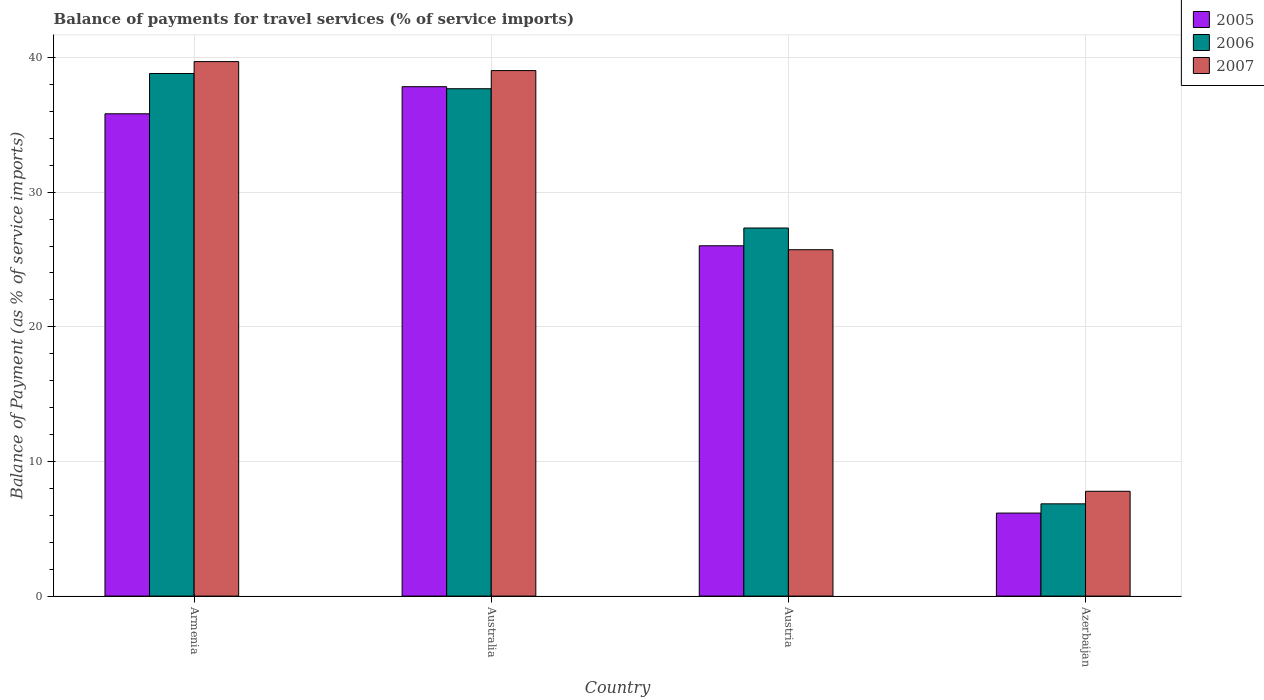How many different coloured bars are there?
Your answer should be compact. 3. Are the number of bars per tick equal to the number of legend labels?
Offer a terse response. Yes. How many bars are there on the 3rd tick from the right?
Keep it short and to the point. 3. What is the label of the 1st group of bars from the left?
Keep it short and to the point. Armenia. What is the balance of payments for travel services in 2005 in Armenia?
Your answer should be very brief. 35.82. Across all countries, what is the maximum balance of payments for travel services in 2006?
Provide a succinct answer. 38.81. Across all countries, what is the minimum balance of payments for travel services in 2006?
Make the answer very short. 6.85. In which country was the balance of payments for travel services in 2007 maximum?
Your response must be concise. Armenia. In which country was the balance of payments for travel services in 2006 minimum?
Give a very brief answer. Azerbaijan. What is the total balance of payments for travel services in 2005 in the graph?
Provide a short and direct response. 105.84. What is the difference between the balance of payments for travel services in 2006 in Armenia and that in Australia?
Your answer should be compact. 1.13. What is the difference between the balance of payments for travel services in 2006 in Armenia and the balance of payments for travel services in 2007 in Azerbaijan?
Offer a very short reply. 31.03. What is the average balance of payments for travel services in 2006 per country?
Provide a succinct answer. 27.67. What is the difference between the balance of payments for travel services of/in 2007 and balance of payments for travel services of/in 2006 in Austria?
Provide a succinct answer. -1.61. In how many countries, is the balance of payments for travel services in 2007 greater than 30 %?
Make the answer very short. 2. What is the ratio of the balance of payments for travel services in 2006 in Armenia to that in Australia?
Give a very brief answer. 1.03. Is the difference between the balance of payments for travel services in 2007 in Australia and Austria greater than the difference between the balance of payments for travel services in 2006 in Australia and Austria?
Offer a terse response. Yes. What is the difference between the highest and the second highest balance of payments for travel services in 2007?
Keep it short and to the point. -13.31. What is the difference between the highest and the lowest balance of payments for travel services in 2007?
Offer a very short reply. 31.91. In how many countries, is the balance of payments for travel services in 2005 greater than the average balance of payments for travel services in 2005 taken over all countries?
Offer a very short reply. 2. Is the sum of the balance of payments for travel services in 2006 in Armenia and Australia greater than the maximum balance of payments for travel services in 2007 across all countries?
Your answer should be very brief. Yes. What does the 2nd bar from the left in Azerbaijan represents?
Provide a short and direct response. 2006. How many bars are there?
Your response must be concise. 12. How many countries are there in the graph?
Offer a very short reply. 4. How many legend labels are there?
Your answer should be compact. 3. How are the legend labels stacked?
Make the answer very short. Vertical. What is the title of the graph?
Your answer should be compact. Balance of payments for travel services (% of service imports). Does "2015" appear as one of the legend labels in the graph?
Make the answer very short. No. What is the label or title of the X-axis?
Offer a very short reply. Country. What is the label or title of the Y-axis?
Provide a short and direct response. Balance of Payment (as % of service imports). What is the Balance of Payment (as % of service imports) in 2005 in Armenia?
Your response must be concise. 35.82. What is the Balance of Payment (as % of service imports) of 2006 in Armenia?
Offer a very short reply. 38.81. What is the Balance of Payment (as % of service imports) of 2007 in Armenia?
Your answer should be very brief. 39.7. What is the Balance of Payment (as % of service imports) of 2005 in Australia?
Offer a terse response. 37.83. What is the Balance of Payment (as % of service imports) of 2006 in Australia?
Give a very brief answer. 37.68. What is the Balance of Payment (as % of service imports) of 2007 in Australia?
Ensure brevity in your answer.  39.03. What is the Balance of Payment (as % of service imports) in 2005 in Austria?
Ensure brevity in your answer.  26.02. What is the Balance of Payment (as % of service imports) in 2006 in Austria?
Provide a short and direct response. 27.34. What is the Balance of Payment (as % of service imports) of 2007 in Austria?
Offer a terse response. 25.73. What is the Balance of Payment (as % of service imports) of 2005 in Azerbaijan?
Your response must be concise. 6.17. What is the Balance of Payment (as % of service imports) of 2006 in Azerbaijan?
Your response must be concise. 6.85. What is the Balance of Payment (as % of service imports) in 2007 in Azerbaijan?
Your response must be concise. 7.79. Across all countries, what is the maximum Balance of Payment (as % of service imports) of 2005?
Provide a succinct answer. 37.83. Across all countries, what is the maximum Balance of Payment (as % of service imports) in 2006?
Make the answer very short. 38.81. Across all countries, what is the maximum Balance of Payment (as % of service imports) in 2007?
Make the answer very short. 39.7. Across all countries, what is the minimum Balance of Payment (as % of service imports) in 2005?
Ensure brevity in your answer.  6.17. Across all countries, what is the minimum Balance of Payment (as % of service imports) of 2006?
Offer a very short reply. 6.85. Across all countries, what is the minimum Balance of Payment (as % of service imports) in 2007?
Keep it short and to the point. 7.79. What is the total Balance of Payment (as % of service imports) of 2005 in the graph?
Your answer should be very brief. 105.84. What is the total Balance of Payment (as % of service imports) of 2006 in the graph?
Your answer should be very brief. 110.69. What is the total Balance of Payment (as % of service imports) of 2007 in the graph?
Your answer should be very brief. 112.24. What is the difference between the Balance of Payment (as % of service imports) in 2005 in Armenia and that in Australia?
Provide a short and direct response. -2.01. What is the difference between the Balance of Payment (as % of service imports) in 2006 in Armenia and that in Australia?
Make the answer very short. 1.13. What is the difference between the Balance of Payment (as % of service imports) in 2007 in Armenia and that in Australia?
Your answer should be very brief. 0.67. What is the difference between the Balance of Payment (as % of service imports) of 2005 in Armenia and that in Austria?
Provide a succinct answer. 9.8. What is the difference between the Balance of Payment (as % of service imports) in 2006 in Armenia and that in Austria?
Provide a short and direct response. 11.47. What is the difference between the Balance of Payment (as % of service imports) of 2007 in Armenia and that in Austria?
Offer a terse response. 13.97. What is the difference between the Balance of Payment (as % of service imports) of 2005 in Armenia and that in Azerbaijan?
Give a very brief answer. 29.66. What is the difference between the Balance of Payment (as % of service imports) in 2006 in Armenia and that in Azerbaijan?
Make the answer very short. 31.96. What is the difference between the Balance of Payment (as % of service imports) in 2007 in Armenia and that in Azerbaijan?
Provide a succinct answer. 31.91. What is the difference between the Balance of Payment (as % of service imports) of 2005 in Australia and that in Austria?
Make the answer very short. 11.82. What is the difference between the Balance of Payment (as % of service imports) in 2006 in Australia and that in Austria?
Your response must be concise. 10.34. What is the difference between the Balance of Payment (as % of service imports) in 2007 in Australia and that in Austria?
Keep it short and to the point. 13.31. What is the difference between the Balance of Payment (as % of service imports) of 2005 in Australia and that in Azerbaijan?
Keep it short and to the point. 31.67. What is the difference between the Balance of Payment (as % of service imports) of 2006 in Australia and that in Azerbaijan?
Your response must be concise. 30.83. What is the difference between the Balance of Payment (as % of service imports) in 2007 in Australia and that in Azerbaijan?
Make the answer very short. 31.24. What is the difference between the Balance of Payment (as % of service imports) of 2005 in Austria and that in Azerbaijan?
Your answer should be compact. 19.85. What is the difference between the Balance of Payment (as % of service imports) of 2006 in Austria and that in Azerbaijan?
Your answer should be compact. 20.49. What is the difference between the Balance of Payment (as % of service imports) of 2007 in Austria and that in Azerbaijan?
Make the answer very short. 17.94. What is the difference between the Balance of Payment (as % of service imports) of 2005 in Armenia and the Balance of Payment (as % of service imports) of 2006 in Australia?
Provide a short and direct response. -1.86. What is the difference between the Balance of Payment (as % of service imports) in 2005 in Armenia and the Balance of Payment (as % of service imports) in 2007 in Australia?
Offer a very short reply. -3.21. What is the difference between the Balance of Payment (as % of service imports) in 2006 in Armenia and the Balance of Payment (as % of service imports) in 2007 in Australia?
Your answer should be compact. -0.22. What is the difference between the Balance of Payment (as % of service imports) in 2005 in Armenia and the Balance of Payment (as % of service imports) in 2006 in Austria?
Ensure brevity in your answer.  8.48. What is the difference between the Balance of Payment (as % of service imports) of 2005 in Armenia and the Balance of Payment (as % of service imports) of 2007 in Austria?
Give a very brief answer. 10.1. What is the difference between the Balance of Payment (as % of service imports) in 2006 in Armenia and the Balance of Payment (as % of service imports) in 2007 in Austria?
Your answer should be very brief. 13.09. What is the difference between the Balance of Payment (as % of service imports) in 2005 in Armenia and the Balance of Payment (as % of service imports) in 2006 in Azerbaijan?
Provide a short and direct response. 28.97. What is the difference between the Balance of Payment (as % of service imports) of 2005 in Armenia and the Balance of Payment (as % of service imports) of 2007 in Azerbaijan?
Make the answer very short. 28.04. What is the difference between the Balance of Payment (as % of service imports) of 2006 in Armenia and the Balance of Payment (as % of service imports) of 2007 in Azerbaijan?
Keep it short and to the point. 31.03. What is the difference between the Balance of Payment (as % of service imports) in 2005 in Australia and the Balance of Payment (as % of service imports) in 2006 in Austria?
Give a very brief answer. 10.49. What is the difference between the Balance of Payment (as % of service imports) of 2005 in Australia and the Balance of Payment (as % of service imports) of 2007 in Austria?
Ensure brevity in your answer.  12.11. What is the difference between the Balance of Payment (as % of service imports) of 2006 in Australia and the Balance of Payment (as % of service imports) of 2007 in Austria?
Offer a terse response. 11.96. What is the difference between the Balance of Payment (as % of service imports) in 2005 in Australia and the Balance of Payment (as % of service imports) in 2006 in Azerbaijan?
Your response must be concise. 30.98. What is the difference between the Balance of Payment (as % of service imports) in 2005 in Australia and the Balance of Payment (as % of service imports) in 2007 in Azerbaijan?
Provide a succinct answer. 30.05. What is the difference between the Balance of Payment (as % of service imports) in 2006 in Australia and the Balance of Payment (as % of service imports) in 2007 in Azerbaijan?
Keep it short and to the point. 29.9. What is the difference between the Balance of Payment (as % of service imports) of 2005 in Austria and the Balance of Payment (as % of service imports) of 2006 in Azerbaijan?
Offer a very short reply. 19.17. What is the difference between the Balance of Payment (as % of service imports) of 2005 in Austria and the Balance of Payment (as % of service imports) of 2007 in Azerbaijan?
Make the answer very short. 18.23. What is the difference between the Balance of Payment (as % of service imports) of 2006 in Austria and the Balance of Payment (as % of service imports) of 2007 in Azerbaijan?
Give a very brief answer. 19.55. What is the average Balance of Payment (as % of service imports) in 2005 per country?
Provide a succinct answer. 26.46. What is the average Balance of Payment (as % of service imports) of 2006 per country?
Give a very brief answer. 27.67. What is the average Balance of Payment (as % of service imports) of 2007 per country?
Keep it short and to the point. 28.06. What is the difference between the Balance of Payment (as % of service imports) of 2005 and Balance of Payment (as % of service imports) of 2006 in Armenia?
Offer a terse response. -2.99. What is the difference between the Balance of Payment (as % of service imports) of 2005 and Balance of Payment (as % of service imports) of 2007 in Armenia?
Offer a terse response. -3.88. What is the difference between the Balance of Payment (as % of service imports) in 2006 and Balance of Payment (as % of service imports) in 2007 in Armenia?
Provide a succinct answer. -0.89. What is the difference between the Balance of Payment (as % of service imports) in 2005 and Balance of Payment (as % of service imports) in 2006 in Australia?
Your answer should be compact. 0.15. What is the difference between the Balance of Payment (as % of service imports) of 2005 and Balance of Payment (as % of service imports) of 2007 in Australia?
Give a very brief answer. -1.2. What is the difference between the Balance of Payment (as % of service imports) of 2006 and Balance of Payment (as % of service imports) of 2007 in Australia?
Ensure brevity in your answer.  -1.35. What is the difference between the Balance of Payment (as % of service imports) in 2005 and Balance of Payment (as % of service imports) in 2006 in Austria?
Provide a short and direct response. -1.32. What is the difference between the Balance of Payment (as % of service imports) in 2005 and Balance of Payment (as % of service imports) in 2007 in Austria?
Your answer should be compact. 0.29. What is the difference between the Balance of Payment (as % of service imports) in 2006 and Balance of Payment (as % of service imports) in 2007 in Austria?
Your answer should be compact. 1.61. What is the difference between the Balance of Payment (as % of service imports) of 2005 and Balance of Payment (as % of service imports) of 2006 in Azerbaijan?
Ensure brevity in your answer.  -0.69. What is the difference between the Balance of Payment (as % of service imports) of 2005 and Balance of Payment (as % of service imports) of 2007 in Azerbaijan?
Keep it short and to the point. -1.62. What is the difference between the Balance of Payment (as % of service imports) in 2006 and Balance of Payment (as % of service imports) in 2007 in Azerbaijan?
Your response must be concise. -0.93. What is the ratio of the Balance of Payment (as % of service imports) of 2005 in Armenia to that in Australia?
Offer a very short reply. 0.95. What is the ratio of the Balance of Payment (as % of service imports) of 2007 in Armenia to that in Australia?
Your response must be concise. 1.02. What is the ratio of the Balance of Payment (as % of service imports) of 2005 in Armenia to that in Austria?
Your response must be concise. 1.38. What is the ratio of the Balance of Payment (as % of service imports) of 2006 in Armenia to that in Austria?
Make the answer very short. 1.42. What is the ratio of the Balance of Payment (as % of service imports) of 2007 in Armenia to that in Austria?
Provide a succinct answer. 1.54. What is the ratio of the Balance of Payment (as % of service imports) in 2005 in Armenia to that in Azerbaijan?
Ensure brevity in your answer.  5.81. What is the ratio of the Balance of Payment (as % of service imports) in 2006 in Armenia to that in Azerbaijan?
Provide a succinct answer. 5.66. What is the ratio of the Balance of Payment (as % of service imports) of 2007 in Armenia to that in Azerbaijan?
Your response must be concise. 5.1. What is the ratio of the Balance of Payment (as % of service imports) in 2005 in Australia to that in Austria?
Your answer should be compact. 1.45. What is the ratio of the Balance of Payment (as % of service imports) of 2006 in Australia to that in Austria?
Make the answer very short. 1.38. What is the ratio of the Balance of Payment (as % of service imports) in 2007 in Australia to that in Austria?
Your answer should be compact. 1.52. What is the ratio of the Balance of Payment (as % of service imports) in 2005 in Australia to that in Azerbaijan?
Keep it short and to the point. 6.14. What is the ratio of the Balance of Payment (as % of service imports) in 2006 in Australia to that in Azerbaijan?
Provide a succinct answer. 5.5. What is the ratio of the Balance of Payment (as % of service imports) in 2007 in Australia to that in Azerbaijan?
Offer a very short reply. 5.01. What is the ratio of the Balance of Payment (as % of service imports) in 2005 in Austria to that in Azerbaijan?
Keep it short and to the point. 4.22. What is the ratio of the Balance of Payment (as % of service imports) of 2006 in Austria to that in Azerbaijan?
Ensure brevity in your answer.  3.99. What is the ratio of the Balance of Payment (as % of service imports) of 2007 in Austria to that in Azerbaijan?
Your answer should be very brief. 3.3. What is the difference between the highest and the second highest Balance of Payment (as % of service imports) in 2005?
Provide a short and direct response. 2.01. What is the difference between the highest and the second highest Balance of Payment (as % of service imports) of 2006?
Your answer should be compact. 1.13. What is the difference between the highest and the second highest Balance of Payment (as % of service imports) in 2007?
Provide a short and direct response. 0.67. What is the difference between the highest and the lowest Balance of Payment (as % of service imports) in 2005?
Make the answer very short. 31.67. What is the difference between the highest and the lowest Balance of Payment (as % of service imports) in 2006?
Offer a very short reply. 31.96. What is the difference between the highest and the lowest Balance of Payment (as % of service imports) of 2007?
Provide a short and direct response. 31.91. 